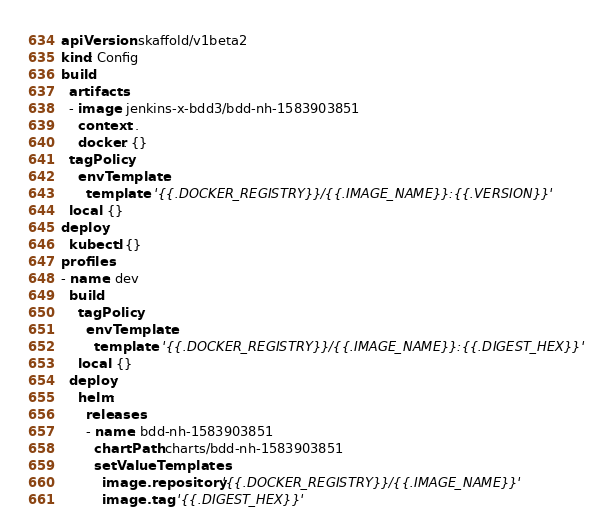Convert code to text. <code><loc_0><loc_0><loc_500><loc_500><_YAML_>apiVersion: skaffold/v1beta2
kind: Config
build:
  artifacts:
  - image: jenkins-x-bdd3/bdd-nh-1583903851
    context: .
    docker: {}
  tagPolicy:
    envTemplate:
      template: '{{.DOCKER_REGISTRY}}/{{.IMAGE_NAME}}:{{.VERSION}}'
  local: {}
deploy:
  kubectl: {}
profiles:
- name: dev
  build:
    tagPolicy:
      envTemplate:
        template: '{{.DOCKER_REGISTRY}}/{{.IMAGE_NAME}}:{{.DIGEST_HEX}}'
    local: {}
  deploy:
    helm:
      releases:
      - name: bdd-nh-1583903851
        chartPath: charts/bdd-nh-1583903851
        setValueTemplates:
          image.repository: '{{.DOCKER_REGISTRY}}/{{.IMAGE_NAME}}'
          image.tag: '{{.DIGEST_HEX}}'
</code> 